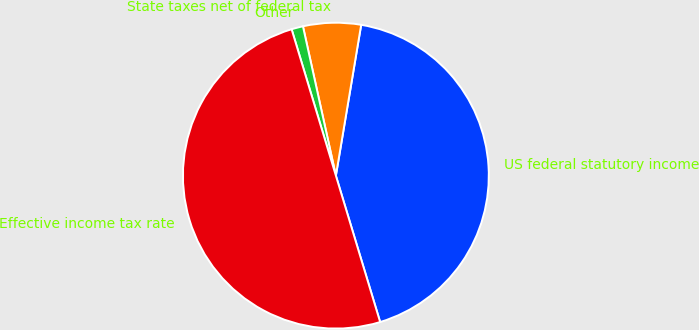Convert chart. <chart><loc_0><loc_0><loc_500><loc_500><pie_chart><fcel>US federal statutory income<fcel>State taxes net of federal tax<fcel>Other<fcel>Effective income tax rate<nl><fcel>42.68%<fcel>6.1%<fcel>1.22%<fcel>50.0%<nl></chart> 